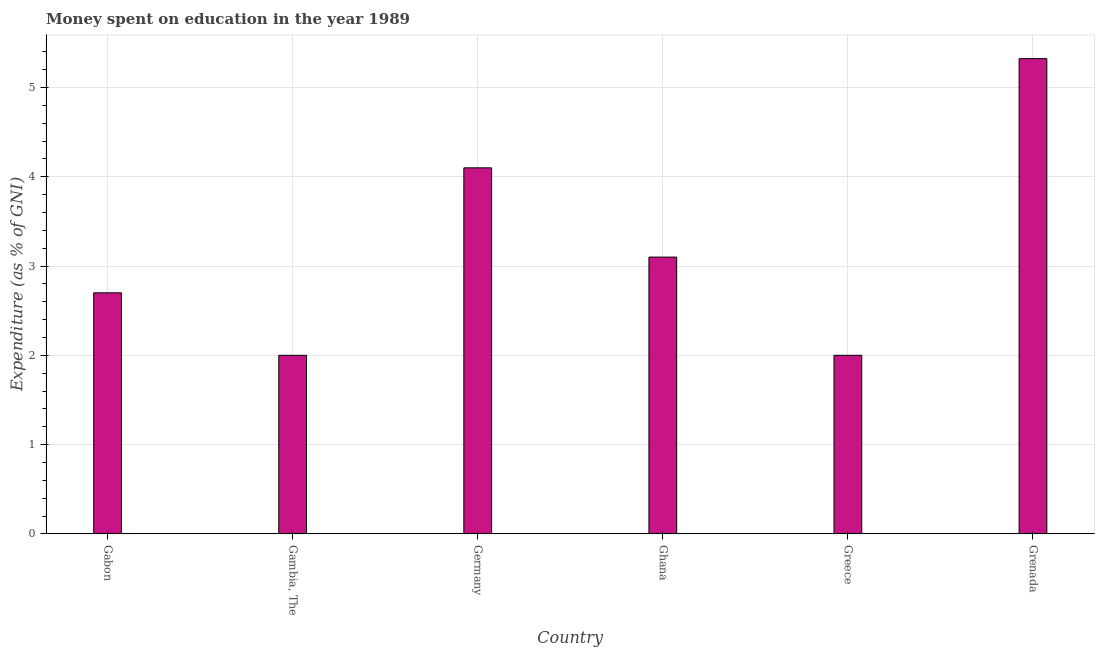Does the graph contain grids?
Provide a succinct answer. Yes. What is the title of the graph?
Keep it short and to the point. Money spent on education in the year 1989. What is the label or title of the X-axis?
Offer a very short reply. Country. What is the label or title of the Y-axis?
Give a very brief answer. Expenditure (as % of GNI). What is the expenditure on education in Grenada?
Provide a short and direct response. 5.32. Across all countries, what is the maximum expenditure on education?
Keep it short and to the point. 5.32. In which country was the expenditure on education maximum?
Your answer should be compact. Grenada. In which country was the expenditure on education minimum?
Your answer should be compact. Gambia, The. What is the sum of the expenditure on education?
Offer a very short reply. 19.22. What is the difference between the expenditure on education in Gambia, The and Grenada?
Make the answer very short. -3.32. What is the average expenditure on education per country?
Make the answer very short. 3.2. What is the median expenditure on education?
Provide a succinct answer. 2.9. In how many countries, is the expenditure on education greater than 0.2 %?
Offer a terse response. 6. What is the ratio of the expenditure on education in Germany to that in Ghana?
Your answer should be very brief. 1.32. Is the expenditure on education in Gambia, The less than that in Greece?
Offer a terse response. No. Is the difference between the expenditure on education in Germany and Grenada greater than the difference between any two countries?
Provide a succinct answer. No. What is the difference between the highest and the second highest expenditure on education?
Offer a very short reply. 1.22. What is the difference between the highest and the lowest expenditure on education?
Provide a short and direct response. 3.32. In how many countries, is the expenditure on education greater than the average expenditure on education taken over all countries?
Provide a short and direct response. 2. How many bars are there?
Offer a terse response. 6. Are the values on the major ticks of Y-axis written in scientific E-notation?
Make the answer very short. No. What is the Expenditure (as % of GNI) of Ghana?
Offer a terse response. 3.1. What is the Expenditure (as % of GNI) in Greece?
Make the answer very short. 2. What is the Expenditure (as % of GNI) in Grenada?
Keep it short and to the point. 5.32. What is the difference between the Expenditure (as % of GNI) in Gabon and Gambia, The?
Offer a very short reply. 0.7. What is the difference between the Expenditure (as % of GNI) in Gabon and Grenada?
Make the answer very short. -2.62. What is the difference between the Expenditure (as % of GNI) in Gambia, The and Ghana?
Your answer should be compact. -1.1. What is the difference between the Expenditure (as % of GNI) in Gambia, The and Grenada?
Your answer should be very brief. -3.32. What is the difference between the Expenditure (as % of GNI) in Germany and Ghana?
Provide a succinct answer. 1. What is the difference between the Expenditure (as % of GNI) in Germany and Grenada?
Provide a short and direct response. -1.22. What is the difference between the Expenditure (as % of GNI) in Ghana and Greece?
Keep it short and to the point. 1.1. What is the difference between the Expenditure (as % of GNI) in Ghana and Grenada?
Make the answer very short. -2.22. What is the difference between the Expenditure (as % of GNI) in Greece and Grenada?
Offer a terse response. -3.32. What is the ratio of the Expenditure (as % of GNI) in Gabon to that in Gambia, The?
Ensure brevity in your answer.  1.35. What is the ratio of the Expenditure (as % of GNI) in Gabon to that in Germany?
Offer a very short reply. 0.66. What is the ratio of the Expenditure (as % of GNI) in Gabon to that in Ghana?
Give a very brief answer. 0.87. What is the ratio of the Expenditure (as % of GNI) in Gabon to that in Greece?
Ensure brevity in your answer.  1.35. What is the ratio of the Expenditure (as % of GNI) in Gabon to that in Grenada?
Ensure brevity in your answer.  0.51. What is the ratio of the Expenditure (as % of GNI) in Gambia, The to that in Germany?
Make the answer very short. 0.49. What is the ratio of the Expenditure (as % of GNI) in Gambia, The to that in Ghana?
Provide a short and direct response. 0.65. What is the ratio of the Expenditure (as % of GNI) in Gambia, The to that in Greece?
Your answer should be very brief. 1. What is the ratio of the Expenditure (as % of GNI) in Gambia, The to that in Grenada?
Offer a terse response. 0.38. What is the ratio of the Expenditure (as % of GNI) in Germany to that in Ghana?
Make the answer very short. 1.32. What is the ratio of the Expenditure (as % of GNI) in Germany to that in Greece?
Give a very brief answer. 2.05. What is the ratio of the Expenditure (as % of GNI) in Germany to that in Grenada?
Your answer should be compact. 0.77. What is the ratio of the Expenditure (as % of GNI) in Ghana to that in Greece?
Offer a terse response. 1.55. What is the ratio of the Expenditure (as % of GNI) in Ghana to that in Grenada?
Ensure brevity in your answer.  0.58. What is the ratio of the Expenditure (as % of GNI) in Greece to that in Grenada?
Your answer should be very brief. 0.38. 